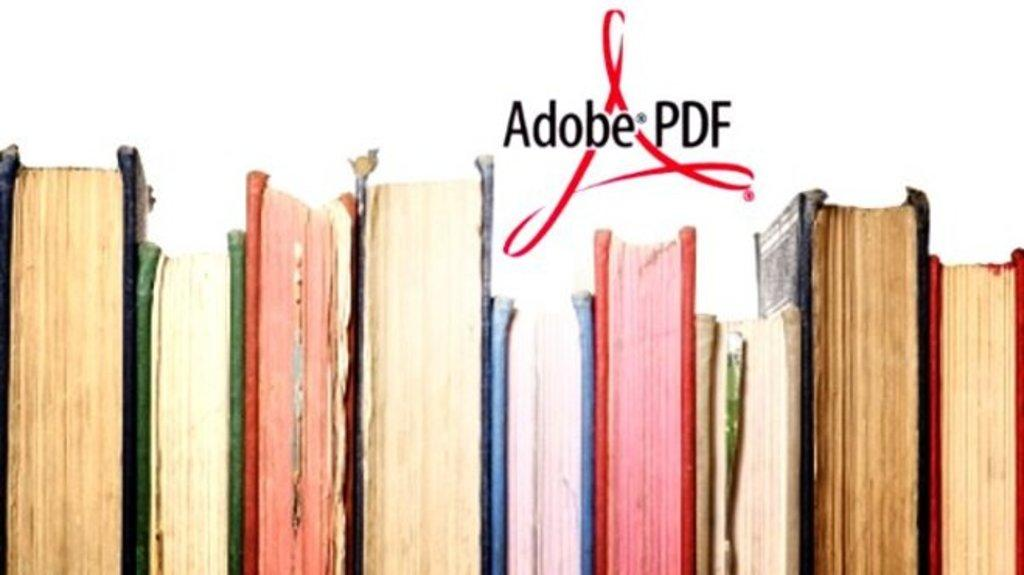<image>
Summarize the visual content of the image. books are lined up, paper side out, as an ad for Adobe PDF 